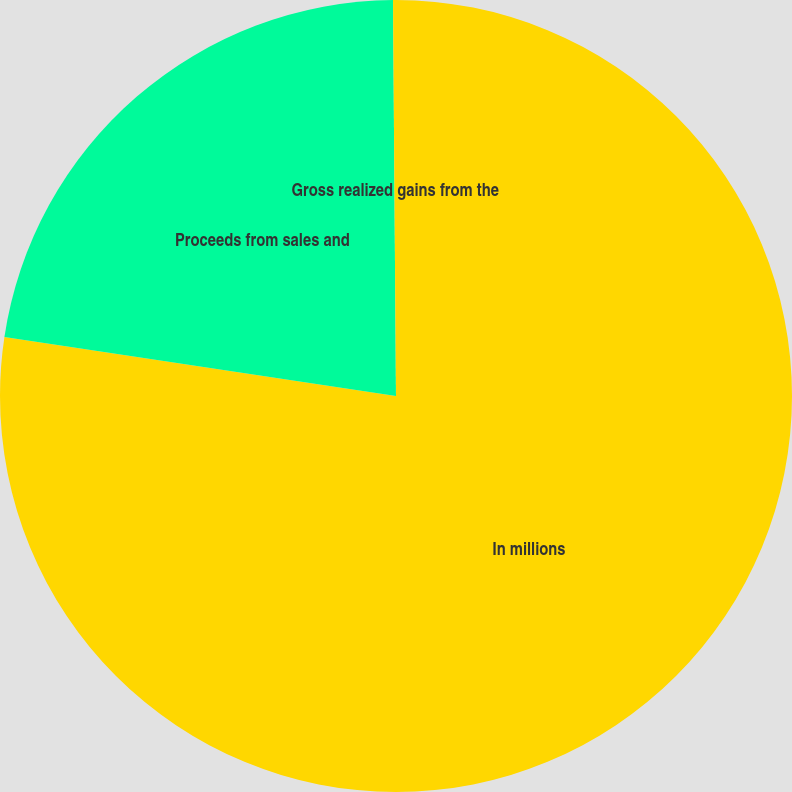Convert chart. <chart><loc_0><loc_0><loc_500><loc_500><pie_chart><fcel>In millions<fcel>Proceeds from sales and<fcel>Gross realized gains from the<nl><fcel>77.38%<fcel>22.5%<fcel>0.12%<nl></chart> 